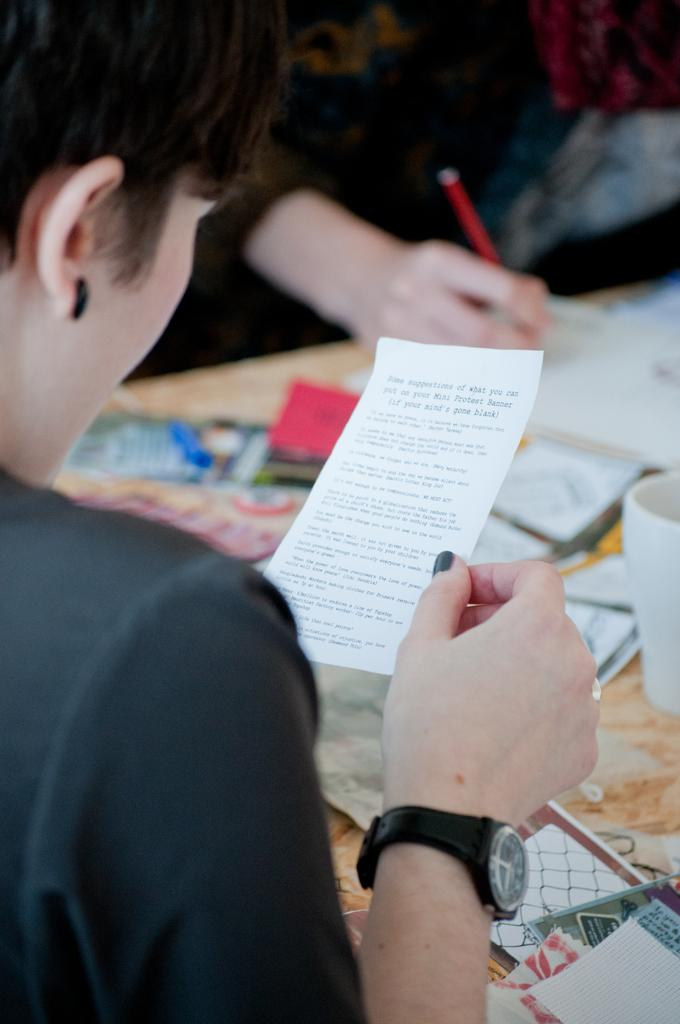How many people are in the image? There are people in the image, but the exact number is not specified. What is present on the table in the image? There is a table in the image, and on it, there is a mug and unspecified things. What is one person holding in the image? One person is holding a paper in the image. What is another person holding in the image? Another person is holding a pen in the image. How many fish are swimming in the mug on the table in the image? There are no fish present in the image, and the mug is not described as containing any liquid or fish. 